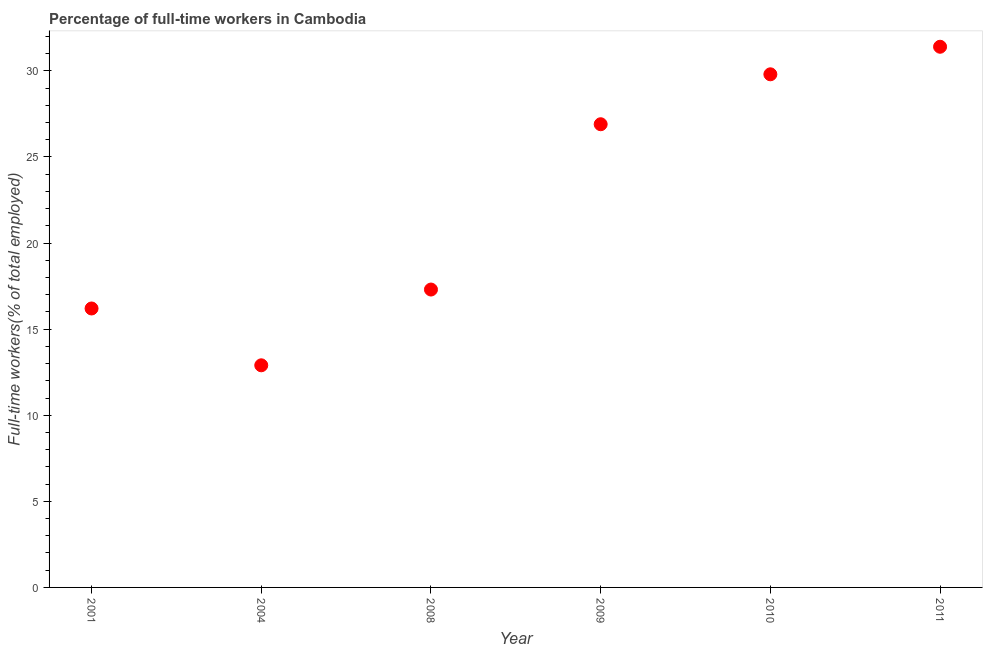What is the percentage of full-time workers in 2008?
Your answer should be compact. 17.3. Across all years, what is the maximum percentage of full-time workers?
Ensure brevity in your answer.  31.4. Across all years, what is the minimum percentage of full-time workers?
Provide a succinct answer. 12.9. In which year was the percentage of full-time workers maximum?
Give a very brief answer. 2011. In which year was the percentage of full-time workers minimum?
Ensure brevity in your answer.  2004. What is the sum of the percentage of full-time workers?
Ensure brevity in your answer.  134.5. What is the average percentage of full-time workers per year?
Give a very brief answer. 22.42. What is the median percentage of full-time workers?
Your response must be concise. 22.1. Do a majority of the years between 2001 and 2009 (inclusive) have percentage of full-time workers greater than 29 %?
Offer a very short reply. No. What is the ratio of the percentage of full-time workers in 2009 to that in 2010?
Offer a terse response. 0.9. Is the difference between the percentage of full-time workers in 2001 and 2009 greater than the difference between any two years?
Your response must be concise. No. What is the difference between the highest and the second highest percentage of full-time workers?
Provide a succinct answer. 1.6. Is the sum of the percentage of full-time workers in 2008 and 2011 greater than the maximum percentage of full-time workers across all years?
Your answer should be very brief. Yes. What is the difference between the highest and the lowest percentage of full-time workers?
Your answer should be very brief. 18.5. How many dotlines are there?
Your response must be concise. 1. What is the difference between two consecutive major ticks on the Y-axis?
Keep it short and to the point. 5. Does the graph contain grids?
Give a very brief answer. No. What is the title of the graph?
Offer a very short reply. Percentage of full-time workers in Cambodia. What is the label or title of the Y-axis?
Give a very brief answer. Full-time workers(% of total employed). What is the Full-time workers(% of total employed) in 2001?
Your answer should be very brief. 16.2. What is the Full-time workers(% of total employed) in 2004?
Your answer should be compact. 12.9. What is the Full-time workers(% of total employed) in 2008?
Ensure brevity in your answer.  17.3. What is the Full-time workers(% of total employed) in 2009?
Your response must be concise. 26.9. What is the Full-time workers(% of total employed) in 2010?
Provide a succinct answer. 29.8. What is the Full-time workers(% of total employed) in 2011?
Your response must be concise. 31.4. What is the difference between the Full-time workers(% of total employed) in 2001 and 2004?
Ensure brevity in your answer.  3.3. What is the difference between the Full-time workers(% of total employed) in 2001 and 2009?
Offer a very short reply. -10.7. What is the difference between the Full-time workers(% of total employed) in 2001 and 2011?
Offer a terse response. -15.2. What is the difference between the Full-time workers(% of total employed) in 2004 and 2010?
Provide a succinct answer. -16.9. What is the difference between the Full-time workers(% of total employed) in 2004 and 2011?
Your answer should be compact. -18.5. What is the difference between the Full-time workers(% of total employed) in 2008 and 2011?
Your response must be concise. -14.1. What is the difference between the Full-time workers(% of total employed) in 2009 and 2010?
Give a very brief answer. -2.9. What is the ratio of the Full-time workers(% of total employed) in 2001 to that in 2004?
Ensure brevity in your answer.  1.26. What is the ratio of the Full-time workers(% of total employed) in 2001 to that in 2008?
Your answer should be compact. 0.94. What is the ratio of the Full-time workers(% of total employed) in 2001 to that in 2009?
Offer a terse response. 0.6. What is the ratio of the Full-time workers(% of total employed) in 2001 to that in 2010?
Give a very brief answer. 0.54. What is the ratio of the Full-time workers(% of total employed) in 2001 to that in 2011?
Keep it short and to the point. 0.52. What is the ratio of the Full-time workers(% of total employed) in 2004 to that in 2008?
Your answer should be compact. 0.75. What is the ratio of the Full-time workers(% of total employed) in 2004 to that in 2009?
Your answer should be compact. 0.48. What is the ratio of the Full-time workers(% of total employed) in 2004 to that in 2010?
Make the answer very short. 0.43. What is the ratio of the Full-time workers(% of total employed) in 2004 to that in 2011?
Give a very brief answer. 0.41. What is the ratio of the Full-time workers(% of total employed) in 2008 to that in 2009?
Your response must be concise. 0.64. What is the ratio of the Full-time workers(% of total employed) in 2008 to that in 2010?
Your answer should be compact. 0.58. What is the ratio of the Full-time workers(% of total employed) in 2008 to that in 2011?
Provide a short and direct response. 0.55. What is the ratio of the Full-time workers(% of total employed) in 2009 to that in 2010?
Your response must be concise. 0.9. What is the ratio of the Full-time workers(% of total employed) in 2009 to that in 2011?
Your answer should be compact. 0.86. What is the ratio of the Full-time workers(% of total employed) in 2010 to that in 2011?
Ensure brevity in your answer.  0.95. 